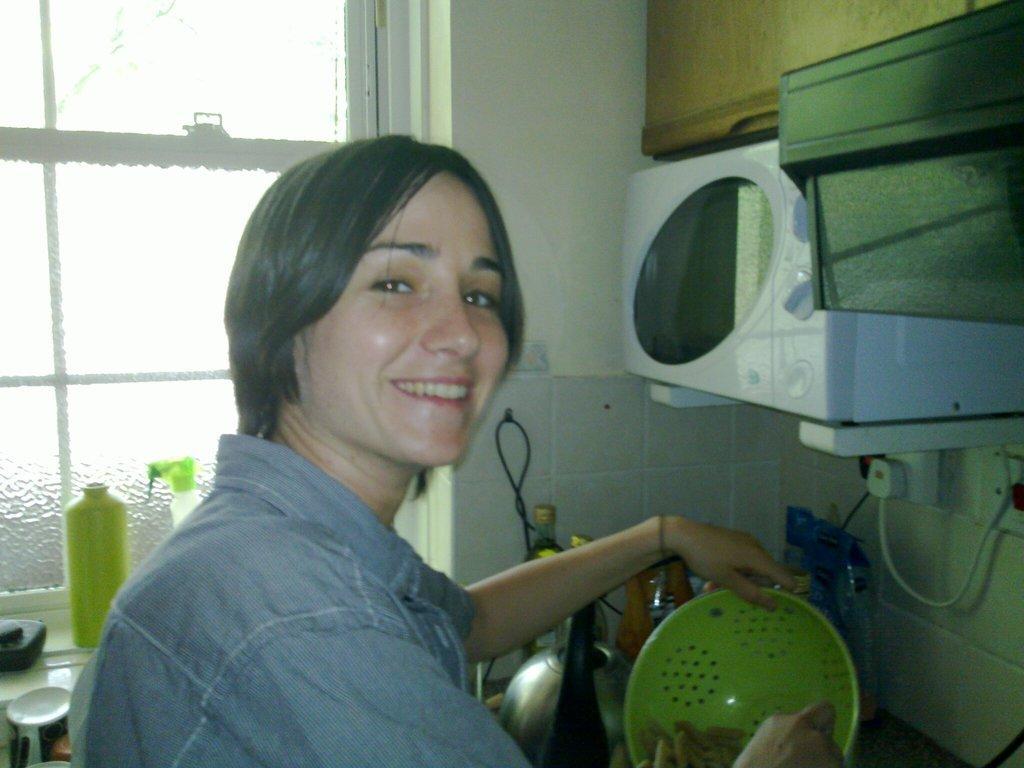In one or two sentences, can you explain what this image depicts? In this image I can see a person wearing shirt is holding a green colored bowl in his hands. I can see the wall, a oven, few wires, few other objects and the window. 